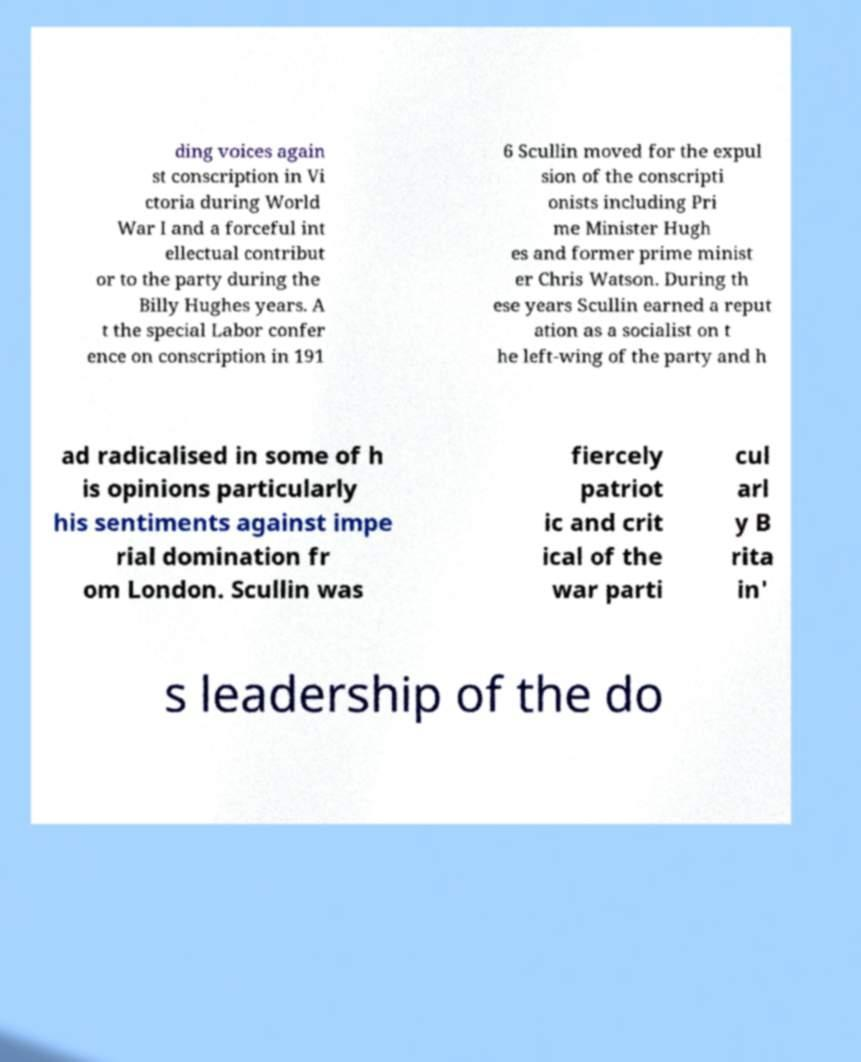I need the written content from this picture converted into text. Can you do that? ding voices again st conscription in Vi ctoria during World War I and a forceful int ellectual contribut or to the party during the Billy Hughes years. A t the special Labor confer ence on conscription in 191 6 Scullin moved for the expul sion of the conscripti onists including Pri me Minister Hugh es and former prime minist er Chris Watson. During th ese years Scullin earned a reput ation as a socialist on t he left-wing of the party and h ad radicalised in some of h is opinions particularly his sentiments against impe rial domination fr om London. Scullin was fiercely patriot ic and crit ical of the war parti cul arl y B rita in' s leadership of the do 